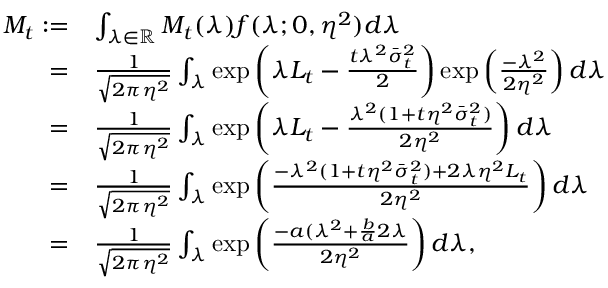Convert formula to latex. <formula><loc_0><loc_0><loc_500><loc_500>\begin{array} { r l } { M _ { t } \colon = } & { \int _ { \lambda \in \mathbb { R } } M _ { t } ( \lambda ) f ( \lambda ; 0 , \eta ^ { 2 } ) d \lambda } \\ { = } & { \frac { 1 } { \sqrt { 2 \pi \eta ^ { 2 } } } \int _ { \lambda } e x p \left ( \lambda L _ { t } - \frac { t \lambda ^ { 2 } \bar { \sigma } _ { t } ^ { 2 } } { 2 } \right ) e x p \left ( \frac { - \lambda ^ { 2 } } { 2 \eta ^ { 2 } } \right ) d \lambda } \\ { = } & { \frac { 1 } { \sqrt { 2 \pi \eta ^ { 2 } } } \int _ { \lambda } e x p \left ( \lambda L _ { t } - \frac { \lambda ^ { 2 } ( 1 + t \eta ^ { 2 } \bar { \sigma } _ { t } ^ { 2 } ) } { 2 \eta ^ { 2 } } \right ) d \lambda } \\ { = } & { \frac { 1 } { \sqrt { 2 \pi \eta ^ { 2 } } } \int _ { \lambda } e x p \left ( \frac { - \lambda ^ { 2 } ( 1 + t \eta ^ { 2 } \bar { \sigma } _ { t } ^ { 2 } ) + 2 \lambda \eta ^ { 2 } L _ { t } } { 2 \eta ^ { 2 } } \right ) d \lambda } \\ { = } & { \frac { 1 } { \sqrt { 2 \pi \eta ^ { 2 } } } \int _ { \lambda } e x p \left ( \frac { - a ( \lambda ^ { 2 } + \frac { b } { a } 2 \lambda } { 2 \eta ^ { 2 } } \right ) d \lambda , } \end{array}</formula> 